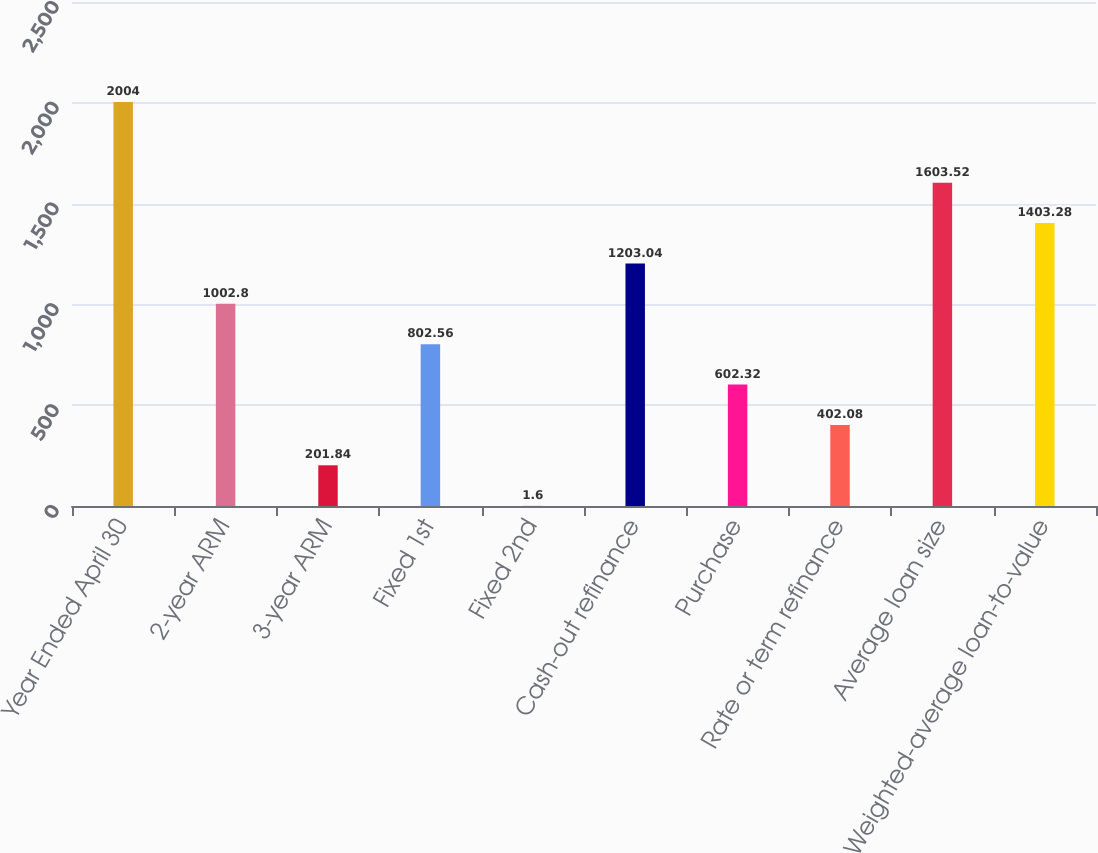Convert chart to OTSL. <chart><loc_0><loc_0><loc_500><loc_500><bar_chart><fcel>Year Ended April 30<fcel>2-year ARM<fcel>3-year ARM<fcel>Fixed 1st<fcel>Fixed 2nd<fcel>Cash-out refinance<fcel>Purchase<fcel>Rate or term refinance<fcel>Average loan size<fcel>Weighted-average loan-to-value<nl><fcel>2004<fcel>1002.8<fcel>201.84<fcel>802.56<fcel>1.6<fcel>1203.04<fcel>602.32<fcel>402.08<fcel>1603.52<fcel>1403.28<nl></chart> 